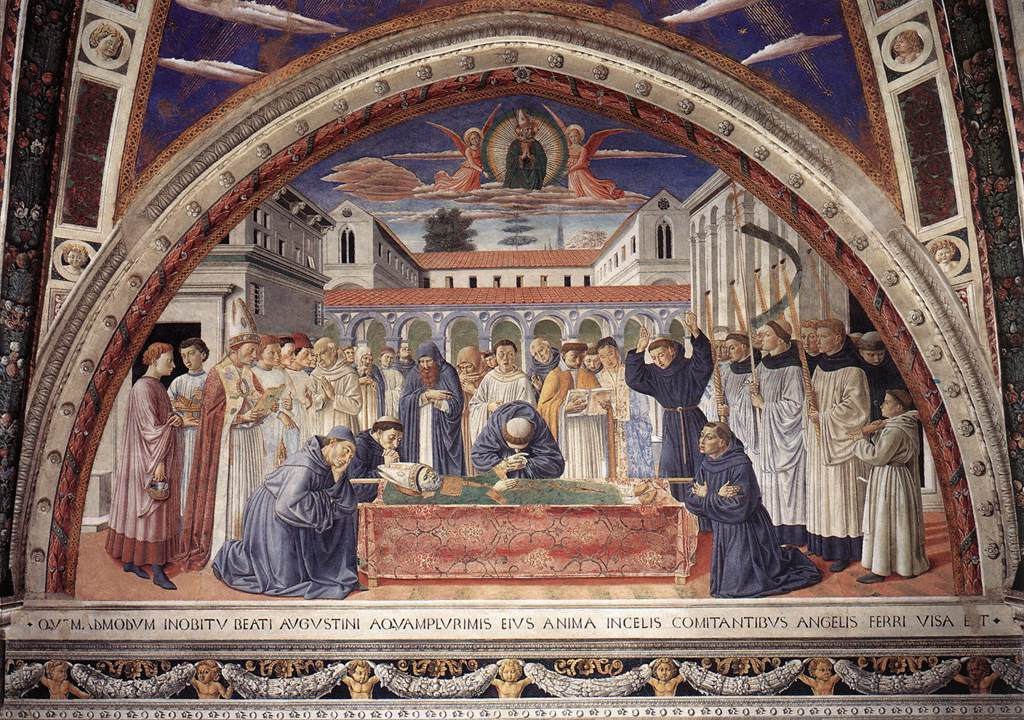What is the significance of medieval clothing in the image? The medieval clothing in the image signifies the historical and cultural context of the scene. It reflects the fashion, social hierarchy, and roles of the period, emphasizing authenticity and immersion. The detailed attire helps identify key figures, such as clergy, royalty, and commoners, providing insight into their status and function within the scene. This clothing also adds to the overall aesthetic, complementing the Gothic architectural elements and enhancing the narrative's richness. Describe the potential religious significance of this painting. The painting likely holds profound religious significance, possibly depicting the death or final moments of a revered saint or religious figure. The gathered crowd, including individuals in clerical garb, suggests a solemn ritual or procession. The serene demeanor of the central figure and the positioning of the surrounding individuals indicate veneration and mourning. The elaborate arch and intricate background further emphasize the sacredness of the event, encapsulating themes of faith, reverence, and the divine in a deeply spiritual narrative. Create a short poem inspired by the painting. In twilight's gentle embrace,
A figure rests in silent grace,
Beneath the arch, in colors bright,
Medieval tales of day and night.

Around the bed, emotions flow,
In reverence, they gently bow,
A story framed in red and gold,
Through Gothic lines, the past unfolds.

Whispers of a sacred lore,
Echo through the arches' door,
In fresco's hues, a life revered,
Timeless moments, held most dear. 